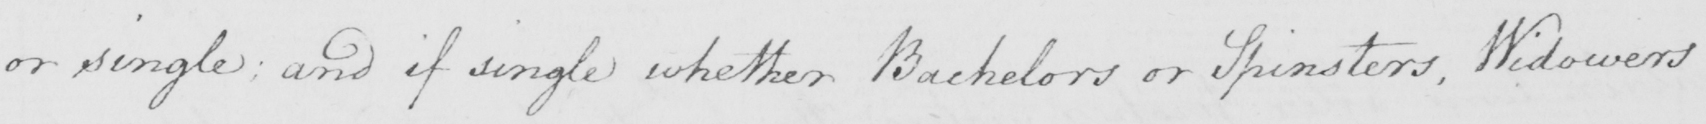What is written in this line of handwriting? or single; and if single whether Bachelors or Spinsters, Widowers 